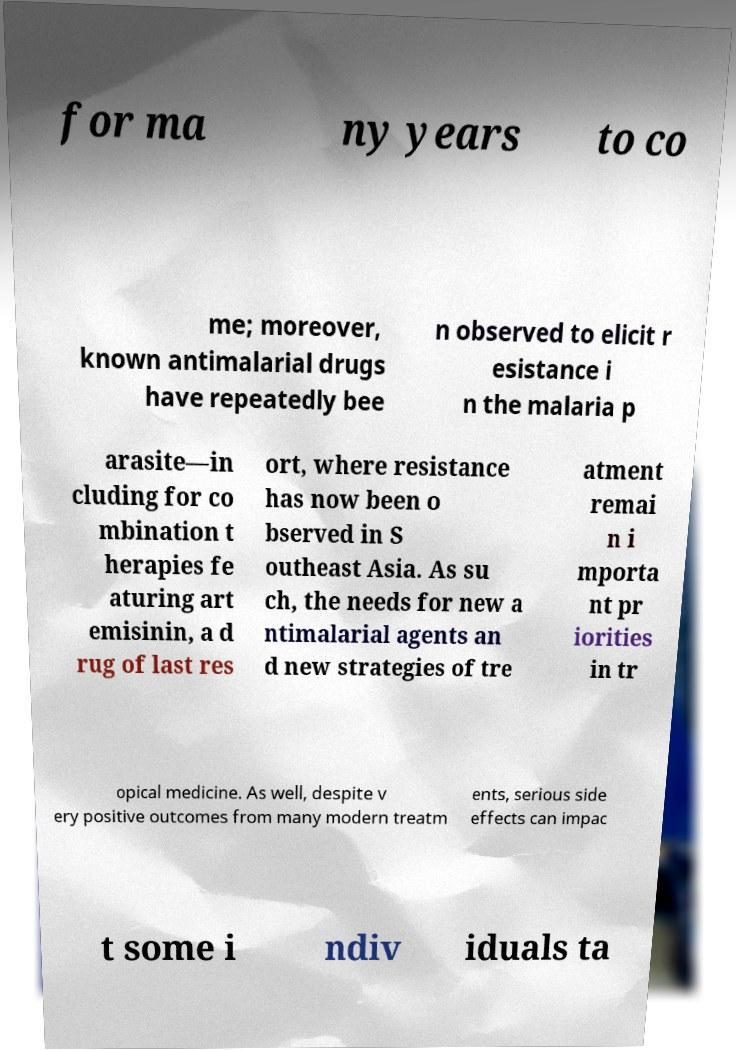What messages or text are displayed in this image? I need them in a readable, typed format. for ma ny years to co me; moreover, known antimalarial drugs have repeatedly bee n observed to elicit r esistance i n the malaria p arasite—in cluding for co mbination t herapies fe aturing art emisinin, a d rug of last res ort, where resistance has now been o bserved in S outheast Asia. As su ch, the needs for new a ntimalarial agents an d new strategies of tre atment remai n i mporta nt pr iorities in tr opical medicine. As well, despite v ery positive outcomes from many modern treatm ents, serious side effects can impac t some i ndiv iduals ta 